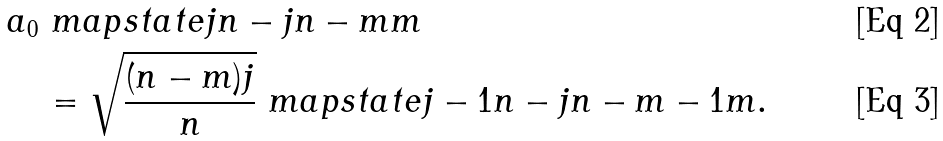<formula> <loc_0><loc_0><loc_500><loc_500>& a _ { 0 } \ m a p s t a t e { j } { n - j } { n - m } { m } \\ & \quad = \sqrt { \frac { ( n - m ) j } { n } } \ m a p s t a t e { j - 1 } { n - j } { n - m - 1 } { m } .</formula> 